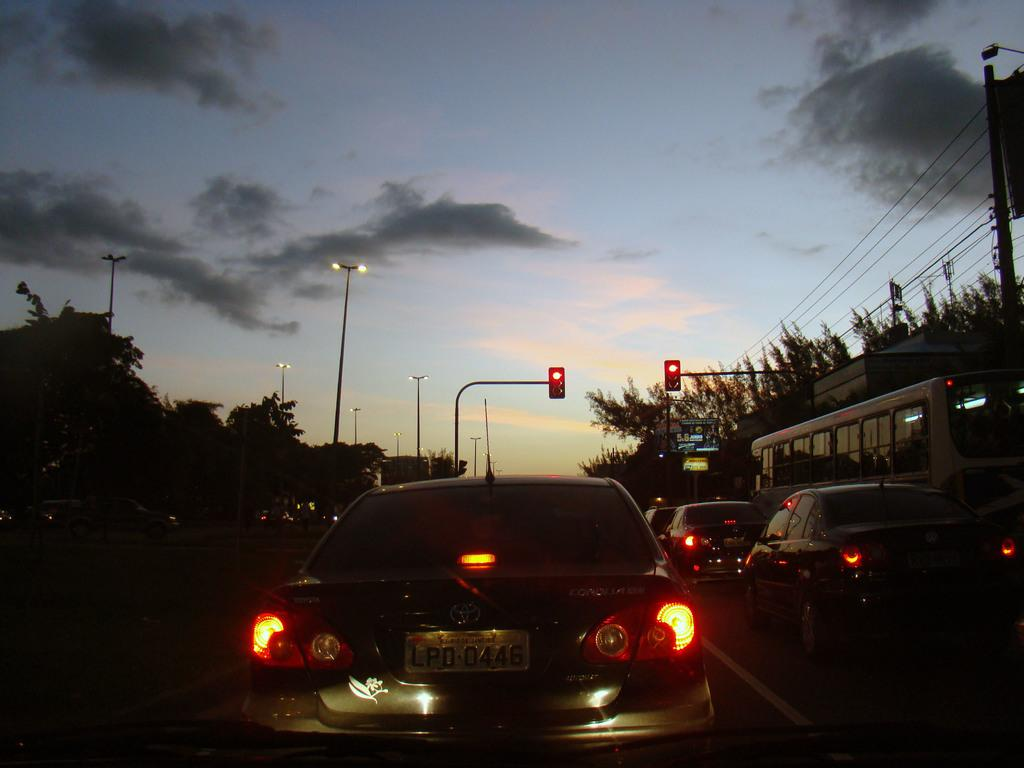What types of vehicles can be seen on the road in the image? There are cars and buses on the road in the image. What else can be seen in the background of the image? There are lights, traffic signals on poles, and the sky visible in the background. What is the purpose of the wind in the image? There is no wind present in the image, so it cannot have a purpose in this context. 